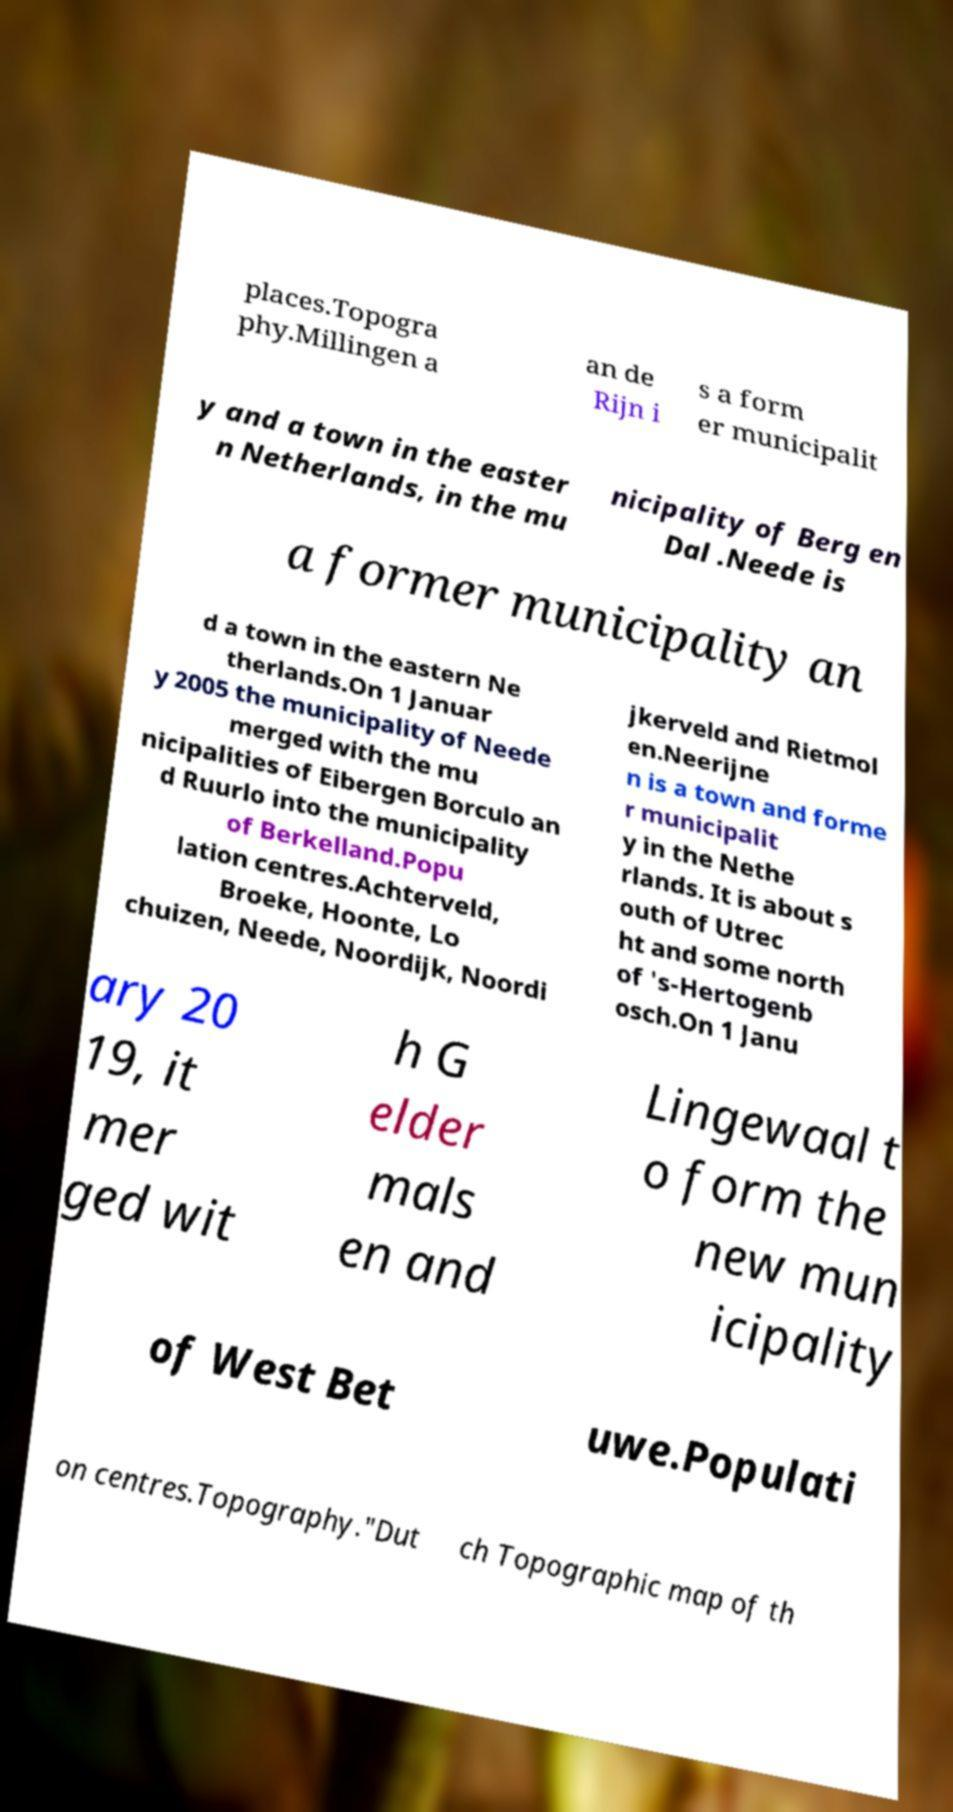What messages or text are displayed in this image? I need them in a readable, typed format. places.Topogra phy.Millingen a an de Rijn i s a form er municipalit y and a town in the easter n Netherlands, in the mu nicipality of Berg en Dal .Neede is a former municipality an d a town in the eastern Ne therlands.On 1 Januar y 2005 the municipality of Neede merged with the mu nicipalities of Eibergen Borculo an d Ruurlo into the municipality of Berkelland.Popu lation centres.Achterveld, Broeke, Hoonte, Lo chuizen, Neede, Noordijk, Noordi jkerveld and Rietmol en.Neerijne n is a town and forme r municipalit y in the Nethe rlands. It is about s outh of Utrec ht and some north of 's-Hertogenb osch.On 1 Janu ary 20 19, it mer ged wit h G elder mals en and Lingewaal t o form the new mun icipality of West Bet uwe.Populati on centres.Topography."Dut ch Topographic map of th 